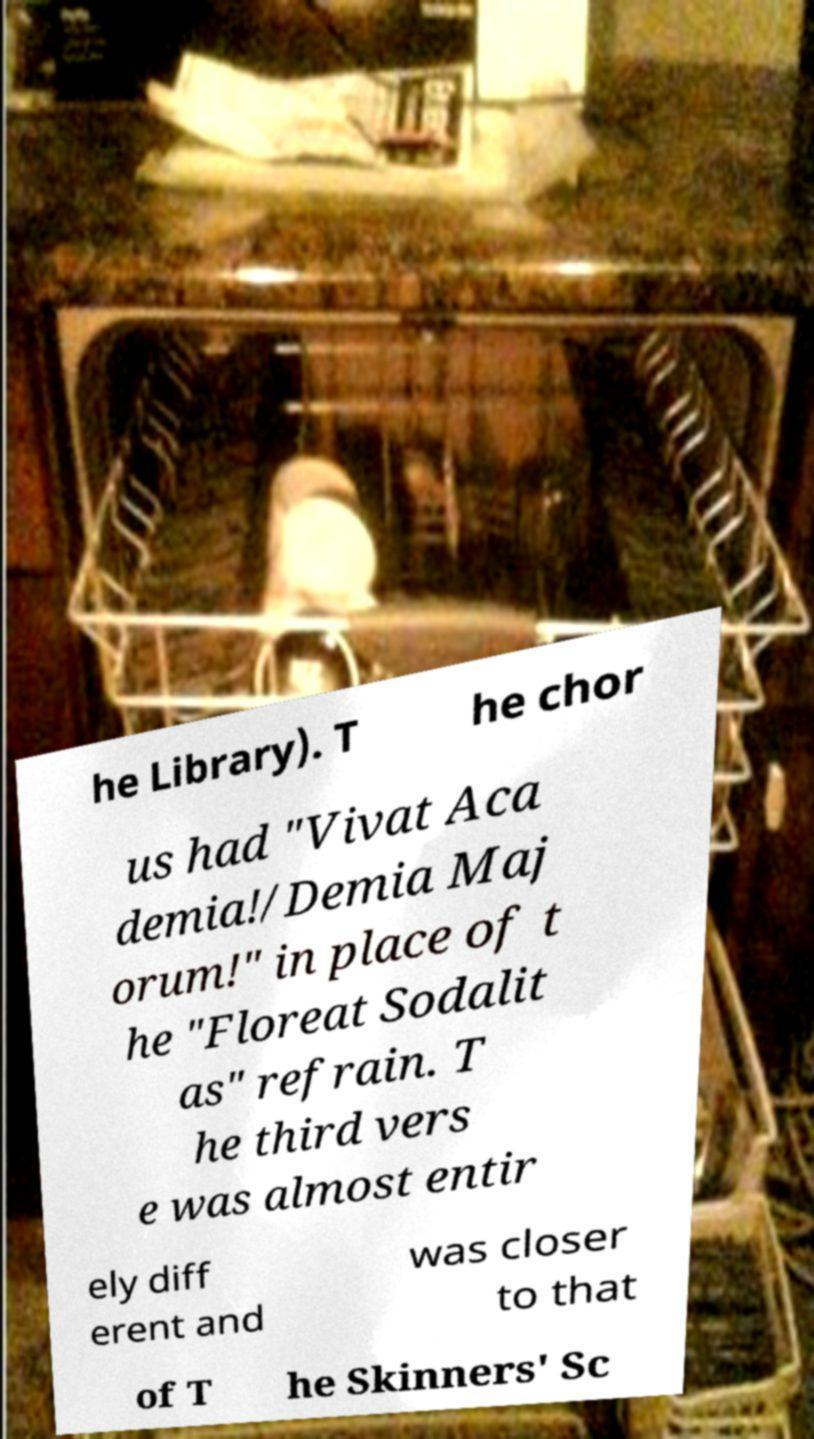Could you extract and type out the text from this image? he Library). T he chor us had "Vivat Aca demia!/Demia Maj orum!" in place of t he "Floreat Sodalit as" refrain. T he third vers e was almost entir ely diff erent and was closer to that of T he Skinners' Sc 